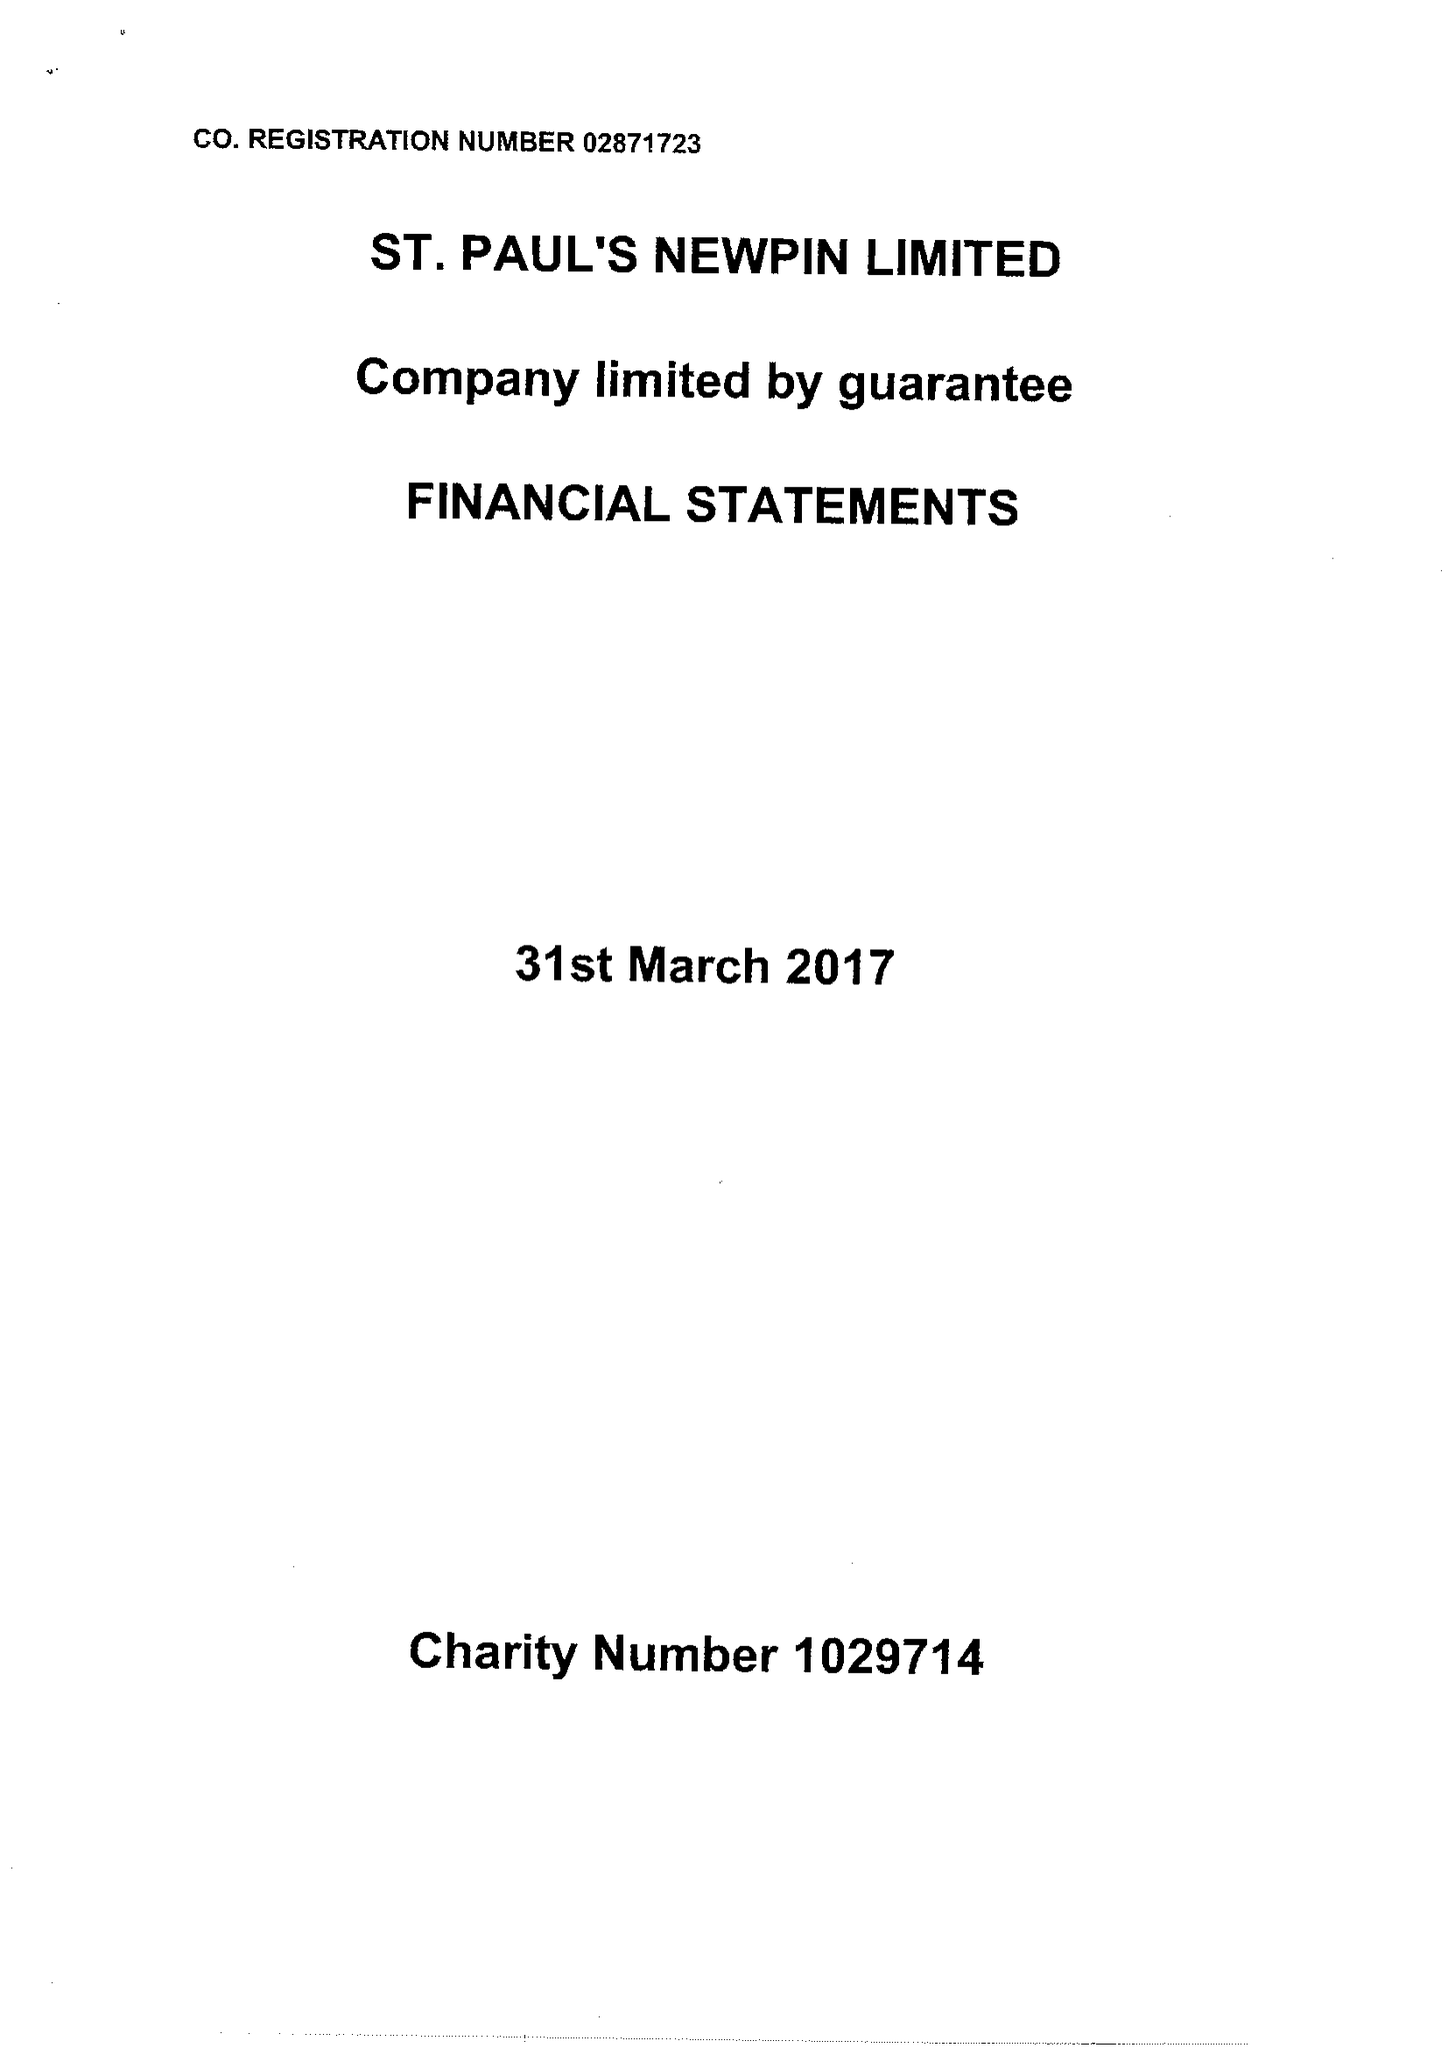What is the value for the address__postcode?
Answer the question using a single word or phrase. NW8 8EQ 